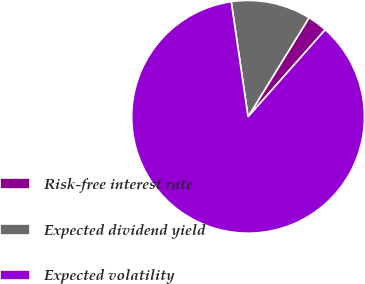Convert chart to OTSL. <chart><loc_0><loc_0><loc_500><loc_500><pie_chart><fcel>Risk-free interest rate<fcel>Expected dividend yield<fcel>Expected volatility<nl><fcel>2.76%<fcel>11.09%<fcel>86.15%<nl></chart> 